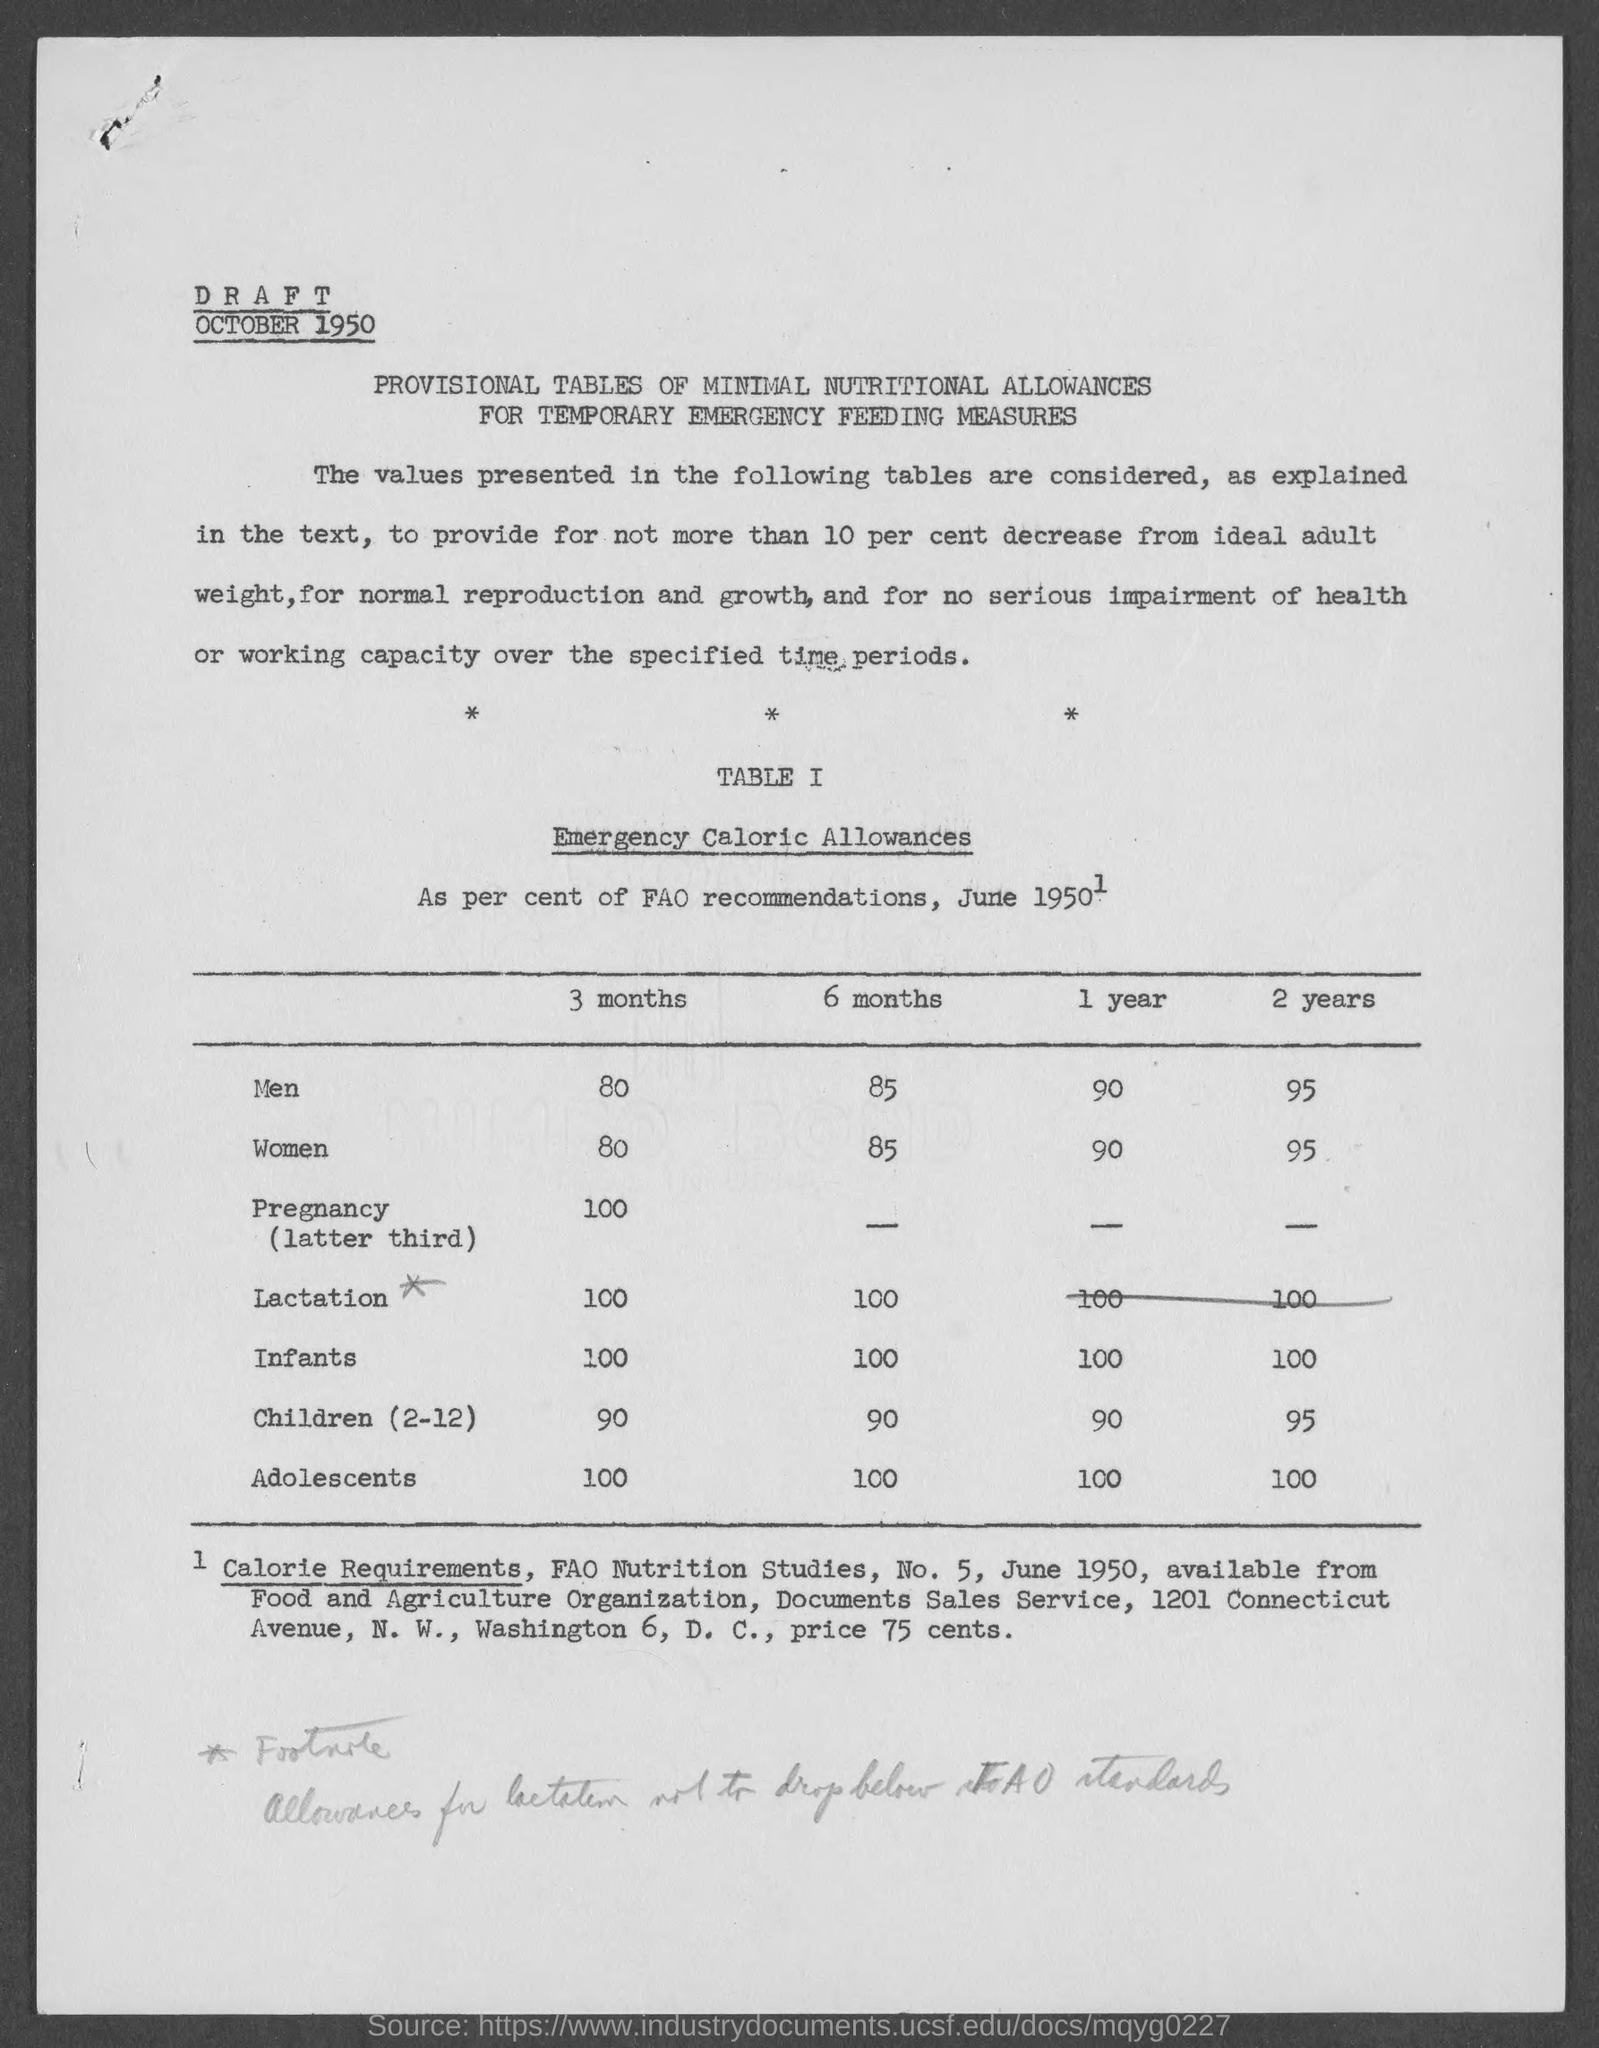Highlight a few significant elements in this photo. The emergency caloric allowance for women for one year is 90,000 calories. The emergency caloric allowance for men for a period of three months is 80. The emergency caloric allowance for women for three months is 80.. The emergency caloric allowance for men for a period of 6 months is 85. The emergency caloric allowance for women for a period of two years is 95 kilocalories per day. 